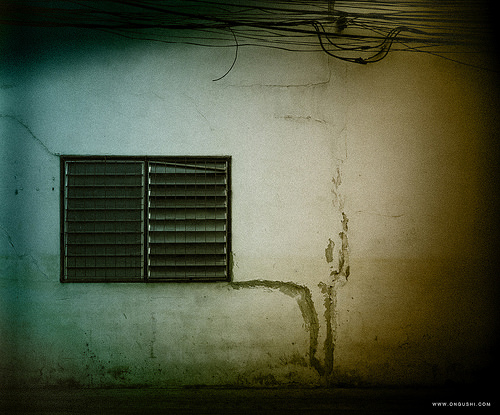<image>
Is the vent in front of the wall? Yes. The vent is positioned in front of the wall, appearing closer to the camera viewpoint. 